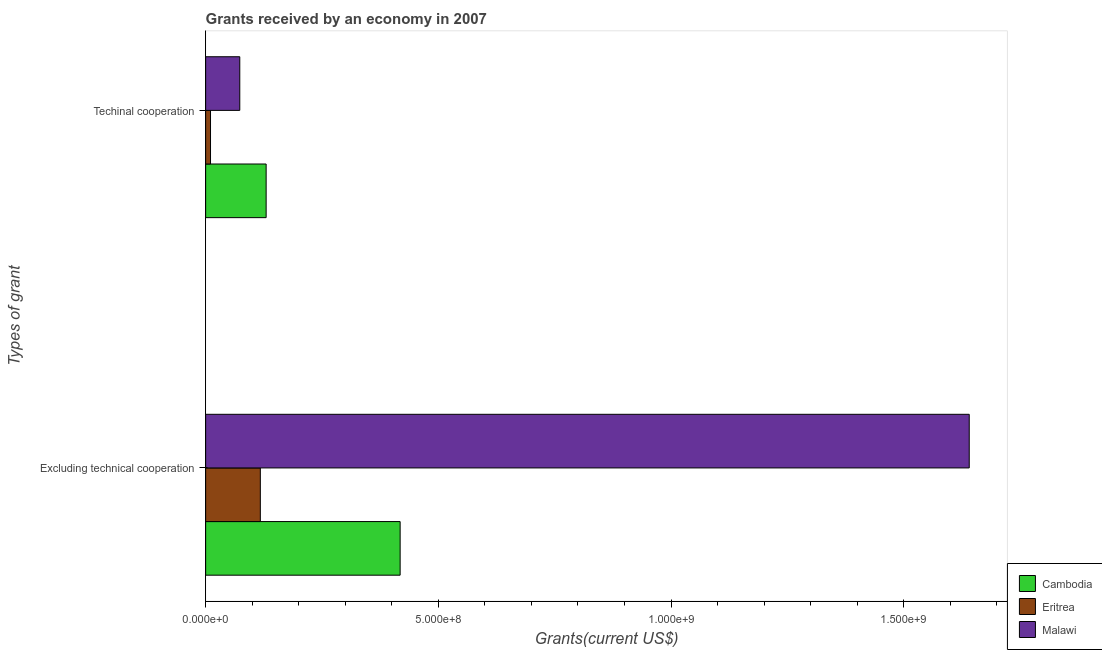How many groups of bars are there?
Your response must be concise. 2. Are the number of bars on each tick of the Y-axis equal?
Make the answer very short. Yes. What is the label of the 1st group of bars from the top?
Keep it short and to the point. Techinal cooperation. What is the amount of grants received(excluding technical cooperation) in Malawi?
Ensure brevity in your answer.  1.64e+09. Across all countries, what is the maximum amount of grants received(including technical cooperation)?
Ensure brevity in your answer.  1.30e+08. Across all countries, what is the minimum amount of grants received(including technical cooperation)?
Provide a succinct answer. 1.05e+07. In which country was the amount of grants received(including technical cooperation) maximum?
Give a very brief answer. Cambodia. In which country was the amount of grants received(excluding technical cooperation) minimum?
Ensure brevity in your answer.  Eritrea. What is the total amount of grants received(including technical cooperation) in the graph?
Your answer should be very brief. 2.14e+08. What is the difference between the amount of grants received(including technical cooperation) in Malawi and that in Eritrea?
Provide a short and direct response. 6.29e+07. What is the difference between the amount of grants received(excluding technical cooperation) in Cambodia and the amount of grants received(including technical cooperation) in Malawi?
Your answer should be very brief. 3.45e+08. What is the average amount of grants received(excluding technical cooperation) per country?
Ensure brevity in your answer.  7.25e+08. What is the difference between the amount of grants received(excluding technical cooperation) and amount of grants received(including technical cooperation) in Cambodia?
Your answer should be very brief. 2.88e+08. In how many countries, is the amount of grants received(excluding technical cooperation) greater than 1500000000 US$?
Offer a terse response. 1. What is the ratio of the amount of grants received(excluding technical cooperation) in Malawi to that in Eritrea?
Give a very brief answer. 13.96. Is the amount of grants received(including technical cooperation) in Malawi less than that in Cambodia?
Provide a succinct answer. Yes. What does the 3rd bar from the top in Techinal cooperation represents?
Give a very brief answer. Cambodia. What does the 1st bar from the bottom in Excluding technical cooperation represents?
Make the answer very short. Cambodia. How many bars are there?
Ensure brevity in your answer.  6. Are all the bars in the graph horizontal?
Ensure brevity in your answer.  Yes. How many countries are there in the graph?
Keep it short and to the point. 3. What is the difference between two consecutive major ticks on the X-axis?
Provide a succinct answer. 5.00e+08. Are the values on the major ticks of X-axis written in scientific E-notation?
Give a very brief answer. Yes. Does the graph contain any zero values?
Keep it short and to the point. No. Does the graph contain grids?
Your answer should be very brief. No. What is the title of the graph?
Your answer should be very brief. Grants received by an economy in 2007. What is the label or title of the X-axis?
Provide a succinct answer. Grants(current US$). What is the label or title of the Y-axis?
Give a very brief answer. Types of grant. What is the Grants(current US$) of Cambodia in Excluding technical cooperation?
Your answer should be compact. 4.18e+08. What is the Grants(current US$) in Eritrea in Excluding technical cooperation?
Keep it short and to the point. 1.18e+08. What is the Grants(current US$) of Malawi in Excluding technical cooperation?
Make the answer very short. 1.64e+09. What is the Grants(current US$) in Cambodia in Techinal cooperation?
Make the answer very short. 1.30e+08. What is the Grants(current US$) in Eritrea in Techinal cooperation?
Offer a terse response. 1.05e+07. What is the Grants(current US$) of Malawi in Techinal cooperation?
Keep it short and to the point. 7.34e+07. Across all Types of grant, what is the maximum Grants(current US$) in Cambodia?
Offer a very short reply. 4.18e+08. Across all Types of grant, what is the maximum Grants(current US$) of Eritrea?
Ensure brevity in your answer.  1.18e+08. Across all Types of grant, what is the maximum Grants(current US$) in Malawi?
Ensure brevity in your answer.  1.64e+09. Across all Types of grant, what is the minimum Grants(current US$) in Cambodia?
Give a very brief answer. 1.30e+08. Across all Types of grant, what is the minimum Grants(current US$) in Eritrea?
Your answer should be very brief. 1.05e+07. Across all Types of grant, what is the minimum Grants(current US$) in Malawi?
Keep it short and to the point. 7.34e+07. What is the total Grants(current US$) of Cambodia in the graph?
Ensure brevity in your answer.  5.48e+08. What is the total Grants(current US$) of Eritrea in the graph?
Your answer should be compact. 1.28e+08. What is the total Grants(current US$) of Malawi in the graph?
Your answer should be very brief. 1.71e+09. What is the difference between the Grants(current US$) in Cambodia in Excluding technical cooperation and that in Techinal cooperation?
Your answer should be compact. 2.88e+08. What is the difference between the Grants(current US$) in Eritrea in Excluding technical cooperation and that in Techinal cooperation?
Provide a short and direct response. 1.07e+08. What is the difference between the Grants(current US$) in Malawi in Excluding technical cooperation and that in Techinal cooperation?
Your response must be concise. 1.57e+09. What is the difference between the Grants(current US$) in Cambodia in Excluding technical cooperation and the Grants(current US$) in Eritrea in Techinal cooperation?
Provide a short and direct response. 4.07e+08. What is the difference between the Grants(current US$) in Cambodia in Excluding technical cooperation and the Grants(current US$) in Malawi in Techinal cooperation?
Ensure brevity in your answer.  3.45e+08. What is the difference between the Grants(current US$) of Eritrea in Excluding technical cooperation and the Grants(current US$) of Malawi in Techinal cooperation?
Make the answer very short. 4.42e+07. What is the average Grants(current US$) of Cambodia per Types of grant?
Provide a succinct answer. 2.74e+08. What is the average Grants(current US$) of Eritrea per Types of grant?
Your answer should be very brief. 6.40e+07. What is the average Grants(current US$) of Malawi per Types of grant?
Offer a very short reply. 8.57e+08. What is the difference between the Grants(current US$) in Cambodia and Grants(current US$) in Eritrea in Excluding technical cooperation?
Offer a terse response. 3.00e+08. What is the difference between the Grants(current US$) of Cambodia and Grants(current US$) of Malawi in Excluding technical cooperation?
Your answer should be compact. -1.22e+09. What is the difference between the Grants(current US$) in Eritrea and Grants(current US$) in Malawi in Excluding technical cooperation?
Offer a very short reply. -1.52e+09. What is the difference between the Grants(current US$) of Cambodia and Grants(current US$) of Eritrea in Techinal cooperation?
Offer a terse response. 1.20e+08. What is the difference between the Grants(current US$) of Cambodia and Grants(current US$) of Malawi in Techinal cooperation?
Provide a succinct answer. 5.66e+07. What is the difference between the Grants(current US$) in Eritrea and Grants(current US$) in Malawi in Techinal cooperation?
Your response must be concise. -6.29e+07. What is the ratio of the Grants(current US$) of Cambodia in Excluding technical cooperation to that in Techinal cooperation?
Your answer should be compact. 3.21. What is the ratio of the Grants(current US$) in Eritrea in Excluding technical cooperation to that in Techinal cooperation?
Make the answer very short. 11.19. What is the ratio of the Grants(current US$) in Malawi in Excluding technical cooperation to that in Techinal cooperation?
Your answer should be very brief. 22.36. What is the difference between the highest and the second highest Grants(current US$) of Cambodia?
Make the answer very short. 2.88e+08. What is the difference between the highest and the second highest Grants(current US$) of Eritrea?
Offer a very short reply. 1.07e+08. What is the difference between the highest and the second highest Grants(current US$) in Malawi?
Your answer should be very brief. 1.57e+09. What is the difference between the highest and the lowest Grants(current US$) of Cambodia?
Provide a succinct answer. 2.88e+08. What is the difference between the highest and the lowest Grants(current US$) in Eritrea?
Ensure brevity in your answer.  1.07e+08. What is the difference between the highest and the lowest Grants(current US$) in Malawi?
Your answer should be compact. 1.57e+09. 